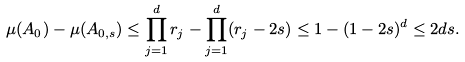Convert formula to latex. <formula><loc_0><loc_0><loc_500><loc_500>\mu ( A _ { 0 } ) - \mu ( A _ { 0 , s } ) \leq \prod _ { j = 1 } ^ { d } r _ { j } - \prod _ { j = 1 } ^ { d } ( r _ { j } - 2 s ) \leq 1 - ( 1 - 2 s ) ^ { d } \leq 2 d s .</formula> 